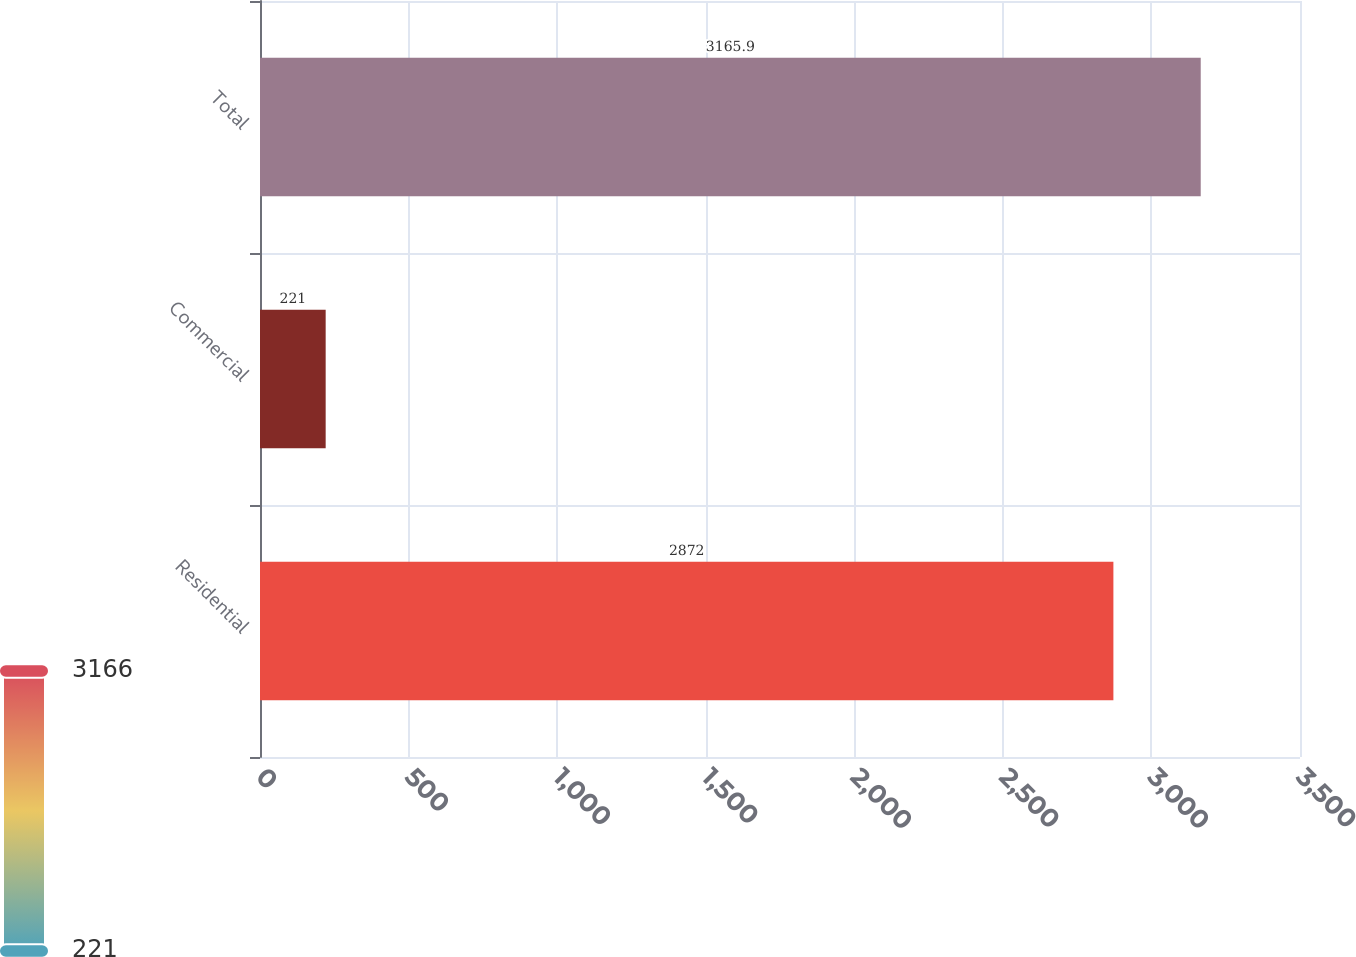Convert chart to OTSL. <chart><loc_0><loc_0><loc_500><loc_500><bar_chart><fcel>Residential<fcel>Commercial<fcel>Total<nl><fcel>2872<fcel>221<fcel>3165.9<nl></chart> 